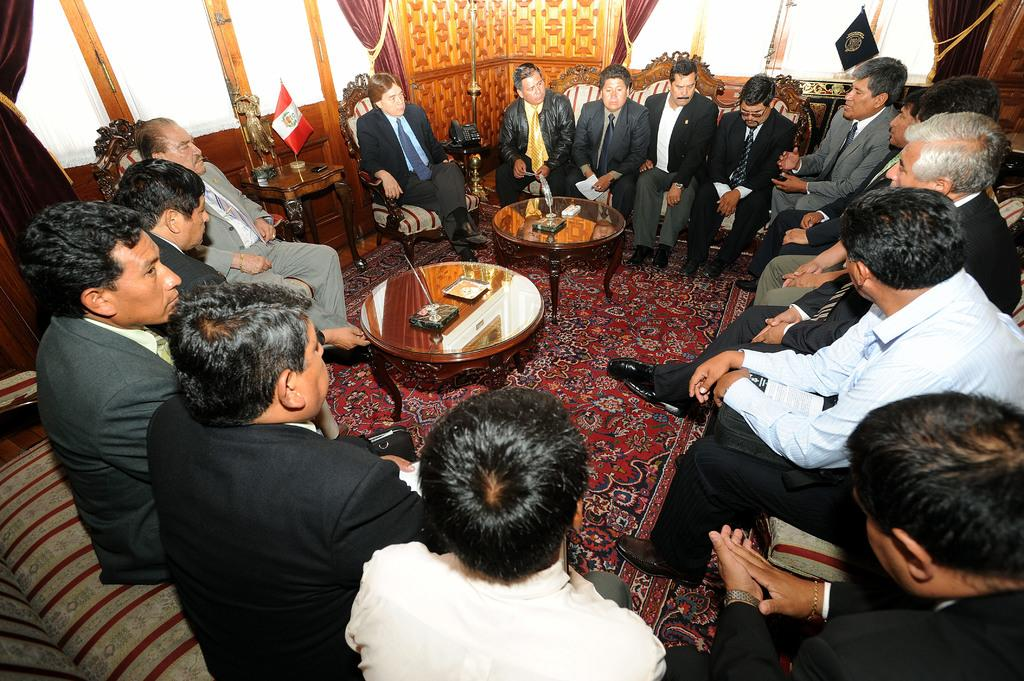What are the people in the image doing? There is a group of people sitting on chairs in the image. Can you describe the person located in the top right of the image? The person on the top right is speaking. What is in the center of the image? There is a wooden table in the center of the image. What can be seen in the image that represents a symbol or group? There is a flag in the image. What type of heart-shaped jewel is the person on the top right wearing in the image? There is no heart-shaped jewel present in the image. What color is the sweater worn by the person on the top right in the image? The person on the top right is not wearing a sweater in the image. 